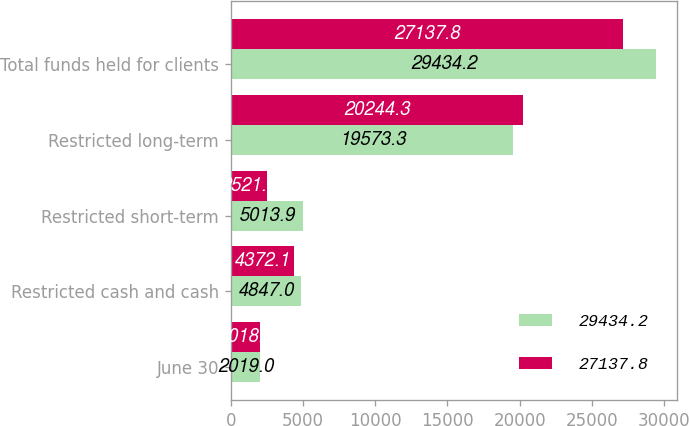Convert chart. <chart><loc_0><loc_0><loc_500><loc_500><stacked_bar_chart><ecel><fcel>June 30<fcel>Restricted cash and cash<fcel>Restricted short-term<fcel>Restricted long-term<fcel>Total funds held for clients<nl><fcel>29434.2<fcel>2019<fcel>4847<fcel>5013.9<fcel>19573.3<fcel>29434.2<nl><fcel>27137.8<fcel>2018<fcel>4372.1<fcel>2521.4<fcel>20244.3<fcel>27137.8<nl></chart> 